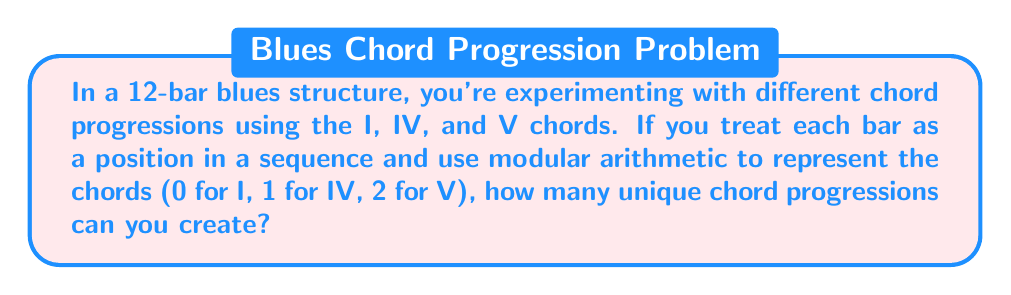Provide a solution to this math problem. Let's approach this step-by-step:

1) In a 12-bar blues structure, we have 12 positions to fill with chords.

2) For each position, we have 3 choices (I, IV, or V chord), which we represent as 0, 1, and 2 in modular arithmetic mod 3.

3) This scenario can be viewed as a sequence of 12 independent choices, where each choice has 3 options.

4) In combinatorics, this is known as the multiplication principle. The total number of possibilities is the product of the number of choices for each position.

5) Mathematically, this can be expressed as:

   $$3^{12}$$

6) To calculate this:
   $$3^{12} = 3 \times 3 \times 3 \times 3 \times 3 \times 3 \times 3 \times 3 \times 3 \times 3 \times 3 \times 3$$

7) This equals 531,441

Therefore, there are 531,441 possible unique chord progressions in a 12-bar blues structure using this modular arithmetic representation.
Answer: 531,441 